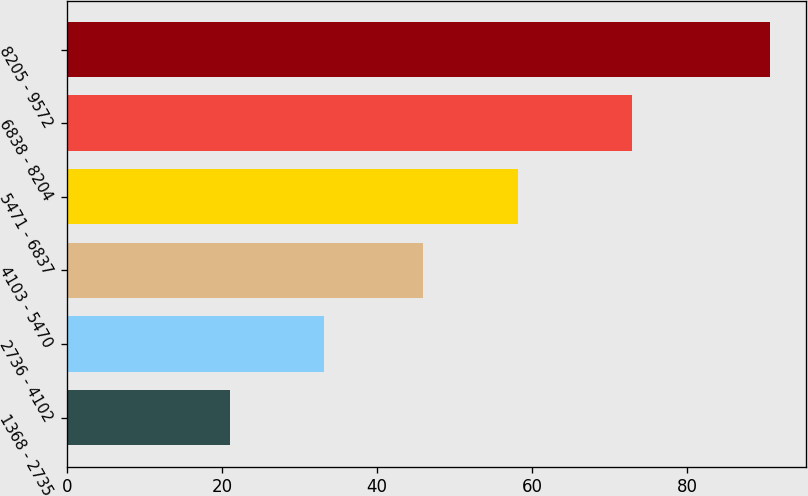<chart> <loc_0><loc_0><loc_500><loc_500><bar_chart><fcel>1368 - 2735<fcel>2736 - 4102<fcel>4103 - 5470<fcel>5471 - 6837<fcel>6838 - 8204<fcel>8205 - 9572<nl><fcel>21.05<fcel>33.18<fcel>45.91<fcel>58.15<fcel>72.89<fcel>90.74<nl></chart> 